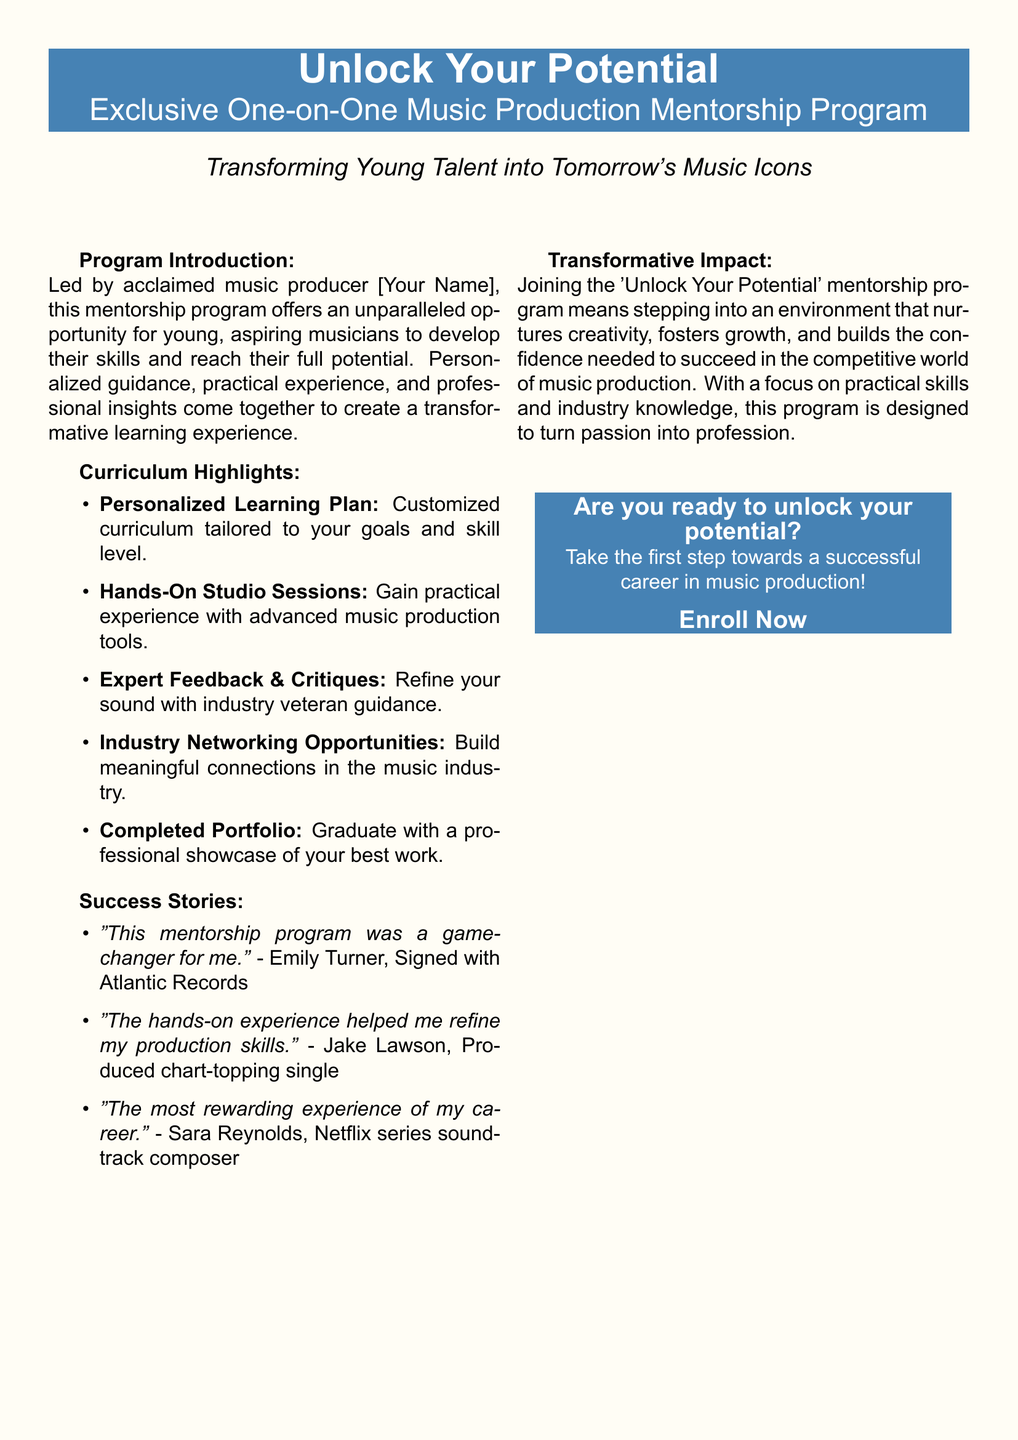What is the name of the program? The program is titled "Unlock Your Potential".
Answer: Unlock Your Potential Who leads the mentorship program? The program is led by an acclaimed music producer referred to as [Your Name].
Answer: [Your Name] What type of learning plan does the program offer? The program offers a "Personalized Learning Plan".
Answer: Personalized Learning Plan Which record label is mentioned in a success story? Emily Turner is signed with a record label mentioned in her success story.
Answer: Atlantic Records What is one of the curriculum highlights involving professional experience? The program includes "Hands-On Studio Sessions".
Answer: Hands-On Studio Sessions How many success stories are shared in the document? There are three success stories shared in the document.
Answer: Three What is the aim of the mentorship program according to the document? The program aims to "turn passion into profession".
Answer: turn passion into profession What call to action is provided at the end? The document encourages readers to "Enroll Now".
Answer: Enroll Now What is emphasized as a key focal point of the program? "Practical skills and industry knowledge" are emphasized as key focal points.
Answer: Practical skills and industry knowledge 